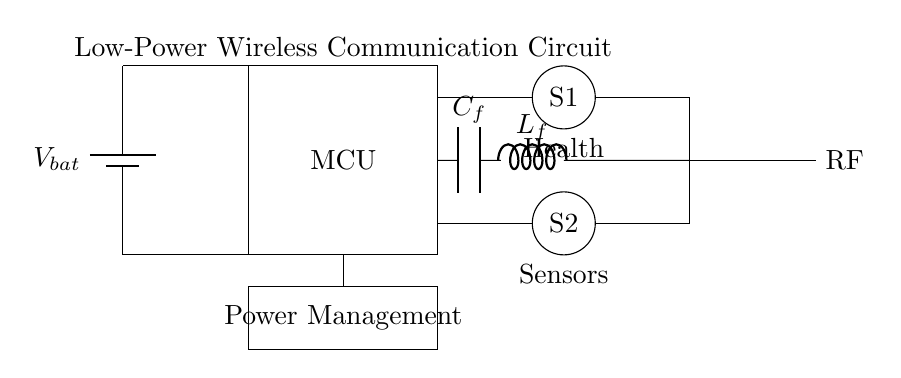What is the main component that processes data in this circuit? The main component that processes data in this circuit is the microcontroller, which is represented by the rectangle labeled "MCU". This component is critical for data handling and control within the circuit.
Answer: microcontroller What type of components are S1 and S2? S1 and S2 are represented as circular shapes in the circuit, indicating that they are sensors. Their placement suggests they are used for health monitoring, gathering relevant data.
Answer: sensors What is the purpose of the low-pass filter in this circuit? The low-pass filter, composed of a capacitor and inductor, is designed to allow low-frequency signals to pass while attenuating higher frequencies. This is essential in wireless communication to reduce noise and enhance signal integrity.
Answer: noise reduction How many sensors are present in this circuit? The circuit diagram shows two sensors labeled S1 and S2, indicating that there are two sensors incorporated into the design for data collection.
Answer: two What component is responsible for power supply in the circuit? The component providing power in this circuit is the battery, depicted with "Vbat". It supplies the necessary voltage for the operation of the microcontroller and other components.
Answer: battery What type of communication does the antenna in the circuit facilitate? The antenna is designed for radio frequency (RF) communication, which allows for wireless transmission of data from the wearable device to other systems, such as smartphones or computers.
Answer: wireless transmission What does the "C_f" represent in the circuit diagram? "C_f" represents the capacitor used in the low-pass filter section of the circuit. Its function is to store charge and help filter out high-frequency noise from the signal.
Answer: capacitor 